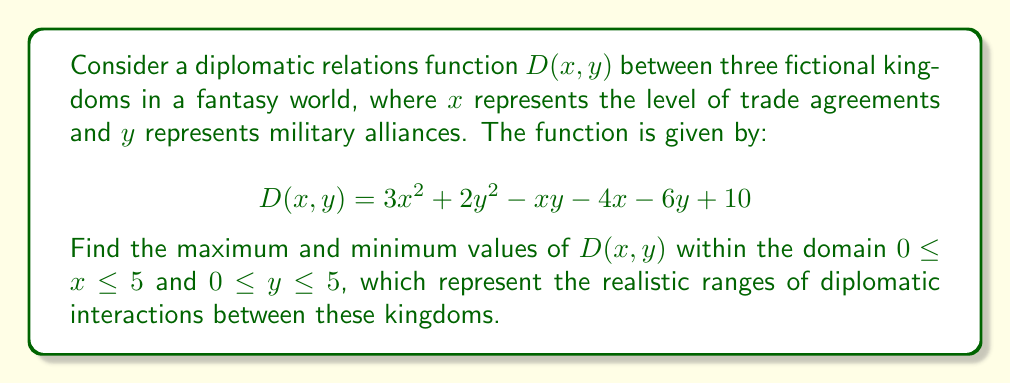Can you answer this question? To find the maximum and minimum values of the multivariable function $D(x, y)$ within the given domain, we'll follow these steps:

1) First, we need to find the critical points by calculating the partial derivatives and setting them to zero:

   $\frac{\partial D}{\partial x} = 6x - y - 4 = 0$
   $\frac{\partial D}{\partial y} = 4y - x - 6 = 0$

2) Solving this system of equations:
   
   $6x - y = 4$
   $-x + 4y = 6$
   
   Multiplying the second equation by 6 and adding to the first:
   
   $23y = 40$
   $y = \frac{40}{23}$
   
   Substituting back:
   
   $x = \frac{44}{23}$

3) The critical point $(\frac{44}{23}, \frac{40}{23})$ is within our domain.

4) Now, we need to check the boundaries of our domain:
   - Along $x = 0$: $D(0, y) = 2y^2 - 6y + 10$
   - Along $x = 5$: $D(5, y) = 75 + 2y^2 - 5y - 20 + 10 = 2y^2 - 5y + 65$
   - Along $y = 0$: $D(x, 0) = 3x^2 - 4x + 10$
   - Along $y = 5$: $D(x, 5) = 3x^2 - x - 4x + 50 - 30 + 10 = 3x^2 - 5x + 30$

5) We find the extrema of these boundary functions:
   - $D(0, y)$ has a minimum at $y = 1.5$, giving $D(0, 1.5) = 5.5$
   - $D(5, y)$ has a minimum at $y = 1.25$, giving $D(5, 1.25) = 61.875$
   - $D(x, 0)$ has a minimum at $x = 2/3$, giving $D(2/3, 0) = 8.667$
   - $D(x, 5)$ has a minimum at $x = 5/6$, giving $D(5/6, 5) = 28.958$

6) We also need to check the corner points:
   $D(0, 0) = 10$
   $D(0, 5) = 35$
   $D(5, 0) = 65$
   $D(5, 5) = 90$

7) Finally, we evaluate $D$ at the critical point:
   $D(\frac{44}{23}, \frac{40}{23}) \approx 7.657$

8) Comparing all these values, we can determine the maximum and minimum.
Answer: The minimum value of $D(x, y)$ in the given domain is approximately 5.5, occurring at $(0, 1.5)$.
The maximum value of $D(x, y)$ in the given domain is 90, occurring at $(5, 5)$. 